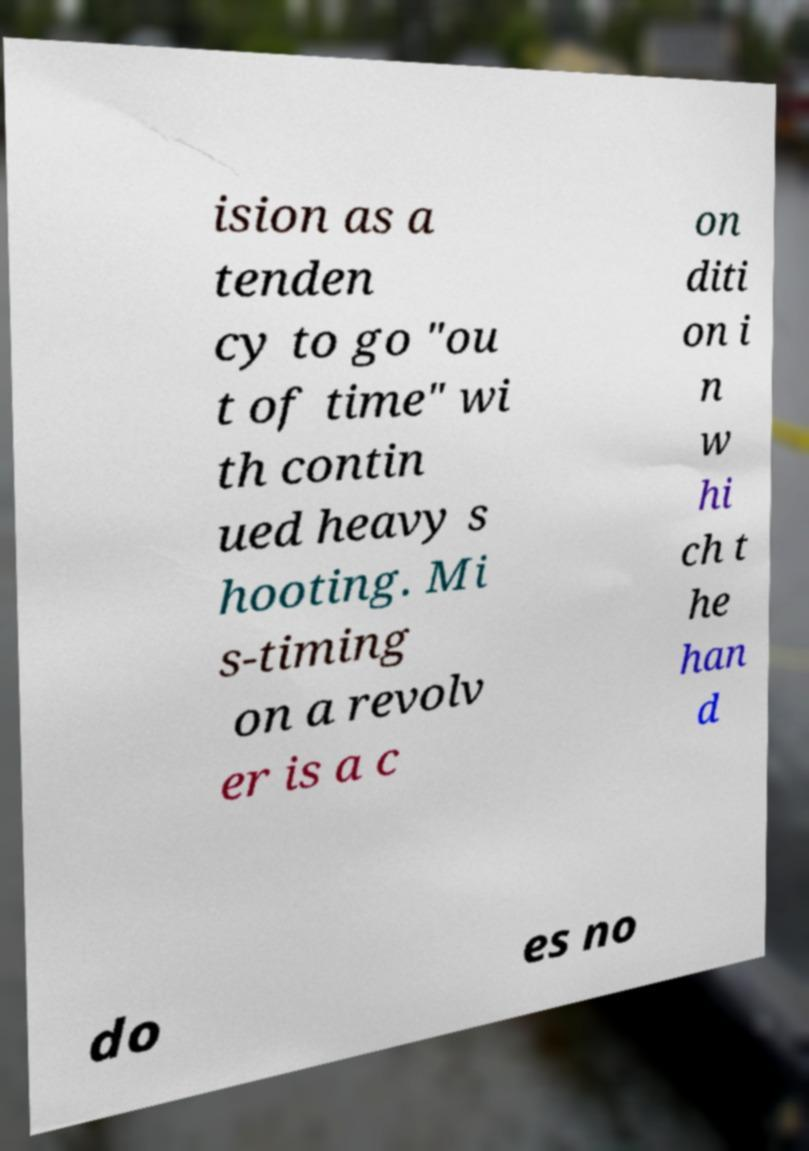For documentation purposes, I need the text within this image transcribed. Could you provide that? ision as a tenden cy to go "ou t of time" wi th contin ued heavy s hooting. Mi s-timing on a revolv er is a c on diti on i n w hi ch t he han d do es no 